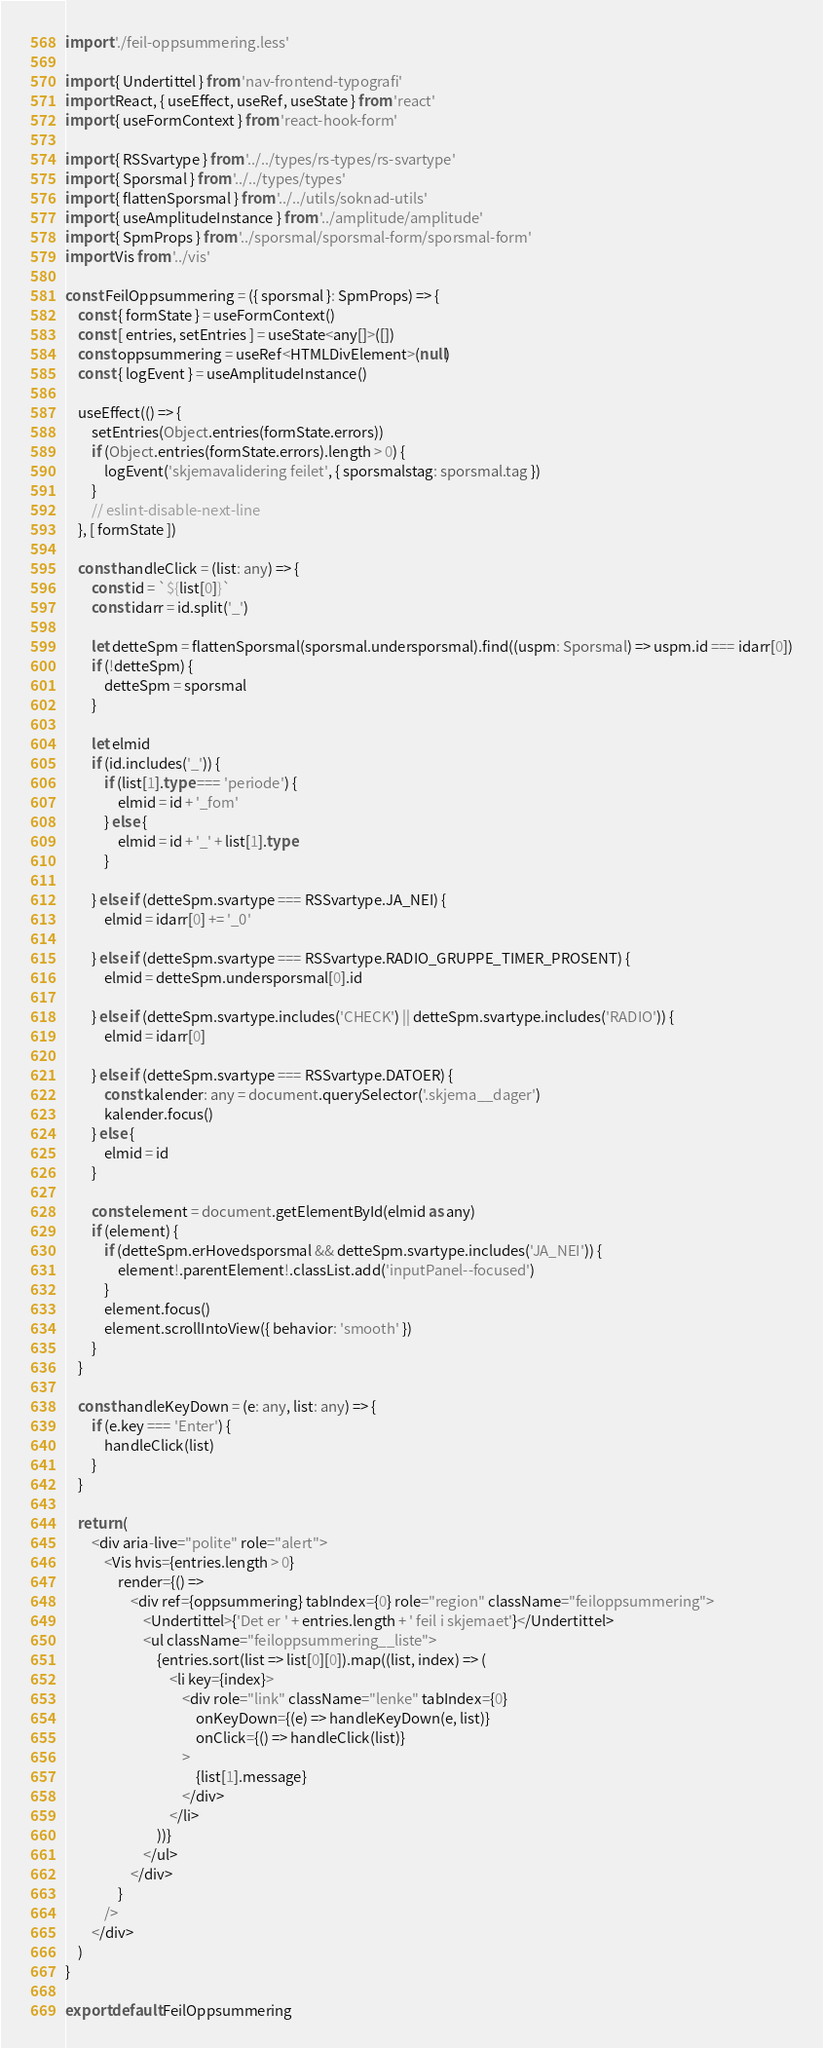Convert code to text. <code><loc_0><loc_0><loc_500><loc_500><_TypeScript_>import './feil-oppsummering.less'

import { Undertittel } from 'nav-frontend-typografi'
import React, { useEffect, useRef, useState } from 'react'
import { useFormContext } from 'react-hook-form'

import { RSSvartype } from '../../types/rs-types/rs-svartype'
import { Sporsmal } from '../../types/types'
import { flattenSporsmal } from '../../utils/soknad-utils'
import { useAmplitudeInstance } from '../amplitude/amplitude'
import { SpmProps } from '../sporsmal/sporsmal-form/sporsmal-form'
import Vis from '../vis'

const FeilOppsummering = ({ sporsmal }: SpmProps) => {
    const { formState } = useFormContext()
    const [ entries, setEntries ] = useState<any[]>([])
    const oppsummering = useRef<HTMLDivElement>(null)
    const { logEvent } = useAmplitudeInstance()

    useEffect(() => {
        setEntries(Object.entries(formState.errors))
        if (Object.entries(formState.errors).length > 0) {
            logEvent('skjemavalidering feilet', { sporsmalstag: sporsmal.tag })
        }
        // eslint-disable-next-line
    }, [ formState ])

    const handleClick = (list: any) => {
        const id = `${list[0]}`
        const idarr = id.split('_')

        let detteSpm = flattenSporsmal(sporsmal.undersporsmal).find((uspm: Sporsmal) => uspm.id === idarr[0])
        if (!detteSpm) {
            detteSpm = sporsmal
        }

        let elmid
        if (id.includes('_')) {
            if (list[1].type === 'periode') {
                elmid = id + '_fom'
            } else {
                elmid = id + '_' + list[1].type
            }

        } else if (detteSpm.svartype === RSSvartype.JA_NEI) {
            elmid = idarr[0] += '_0'

        } else if (detteSpm.svartype === RSSvartype.RADIO_GRUPPE_TIMER_PROSENT) {
            elmid = detteSpm.undersporsmal[0].id

        } else if (detteSpm.svartype.includes('CHECK') || detteSpm.svartype.includes('RADIO')) {
            elmid = idarr[0]

        } else if (detteSpm.svartype === RSSvartype.DATOER) {
            const kalender: any = document.querySelector('.skjema__dager')
            kalender.focus()
        } else {
            elmid = id
        }

        const element = document.getElementById(elmid as any)
        if (element) {
            if (detteSpm.erHovedsporsmal && detteSpm.svartype.includes('JA_NEI')) {
                element!.parentElement!.classList.add('inputPanel--focused')
            }
            element.focus()
            element.scrollIntoView({ behavior: 'smooth' })
        }
    }

    const handleKeyDown = (e: any, list: any) => {
        if (e.key === 'Enter') {
            handleClick(list)
        }
    }

    return (
        <div aria-live="polite" role="alert">
            <Vis hvis={entries.length > 0}
                render={() =>
                    <div ref={oppsummering} tabIndex={0} role="region" className="feiloppsummering">
                        <Undertittel>{'Det er ' + entries.length + ' feil i skjemaet'}</Undertittel>
                        <ul className="feiloppsummering__liste">
                            {entries.sort(list => list[0][0]).map((list, index) => (
                                <li key={index}>
                                    <div role="link" className="lenke" tabIndex={0}
                                        onKeyDown={(e) => handleKeyDown(e, list)}
                                        onClick={() => handleClick(list)}
                                    >
                                        {list[1].message}
                                    </div>
                                </li>
                            ))}
                        </ul>
                    </div>
                }
            />
        </div>
    )
}

export default FeilOppsummering
</code> 